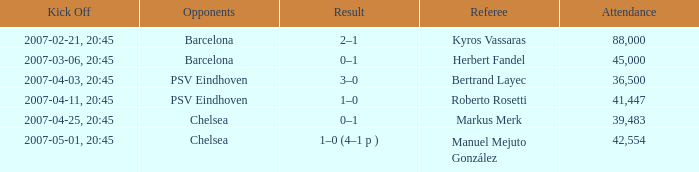WHAT OPPONENT HAD A KICKOFF OF 2007-03-06, 20:45? Barcelona. 